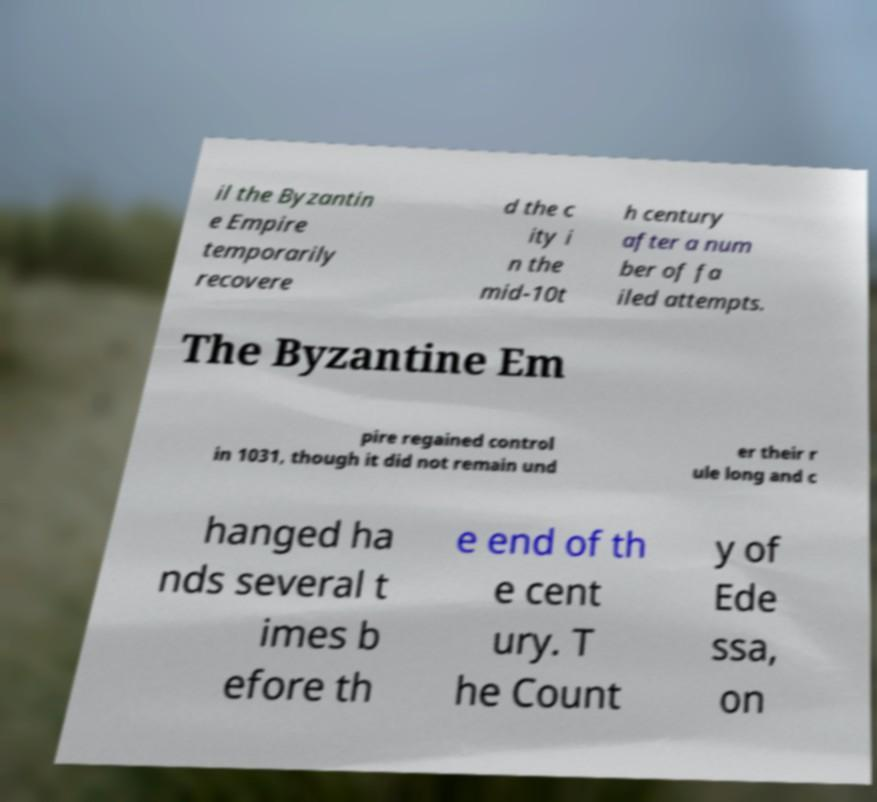I need the written content from this picture converted into text. Can you do that? il the Byzantin e Empire temporarily recovere d the c ity i n the mid-10t h century after a num ber of fa iled attempts. The Byzantine Em pire regained control in 1031, though it did not remain und er their r ule long and c hanged ha nds several t imes b efore th e end of th e cent ury. T he Count y of Ede ssa, on 